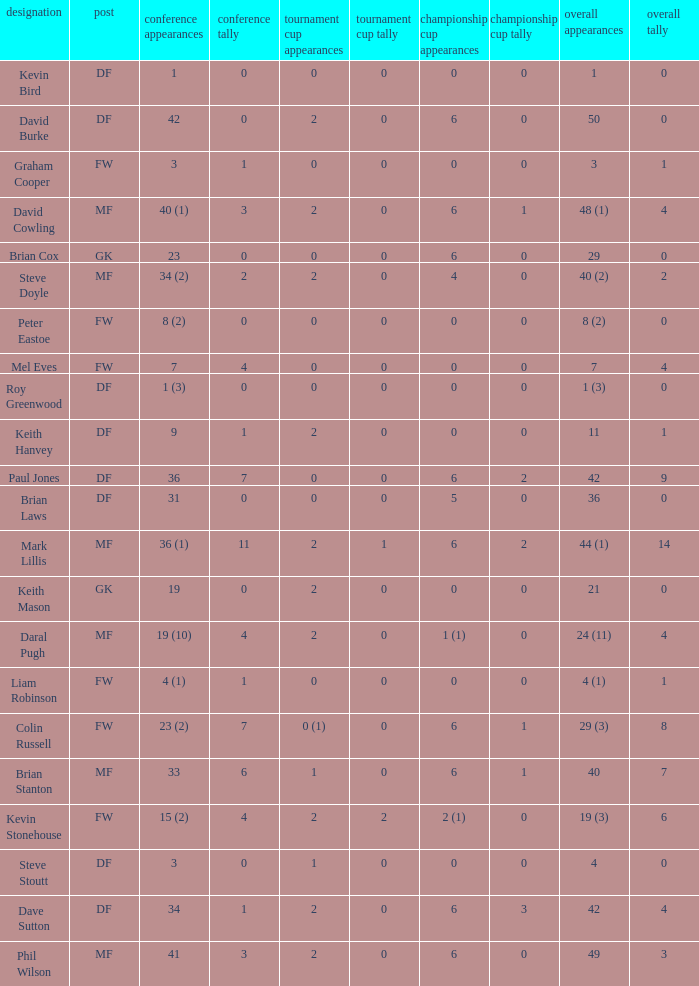What is the most total goals for a player having 0 FA Cup goals and 41 League appearances? 3.0. 